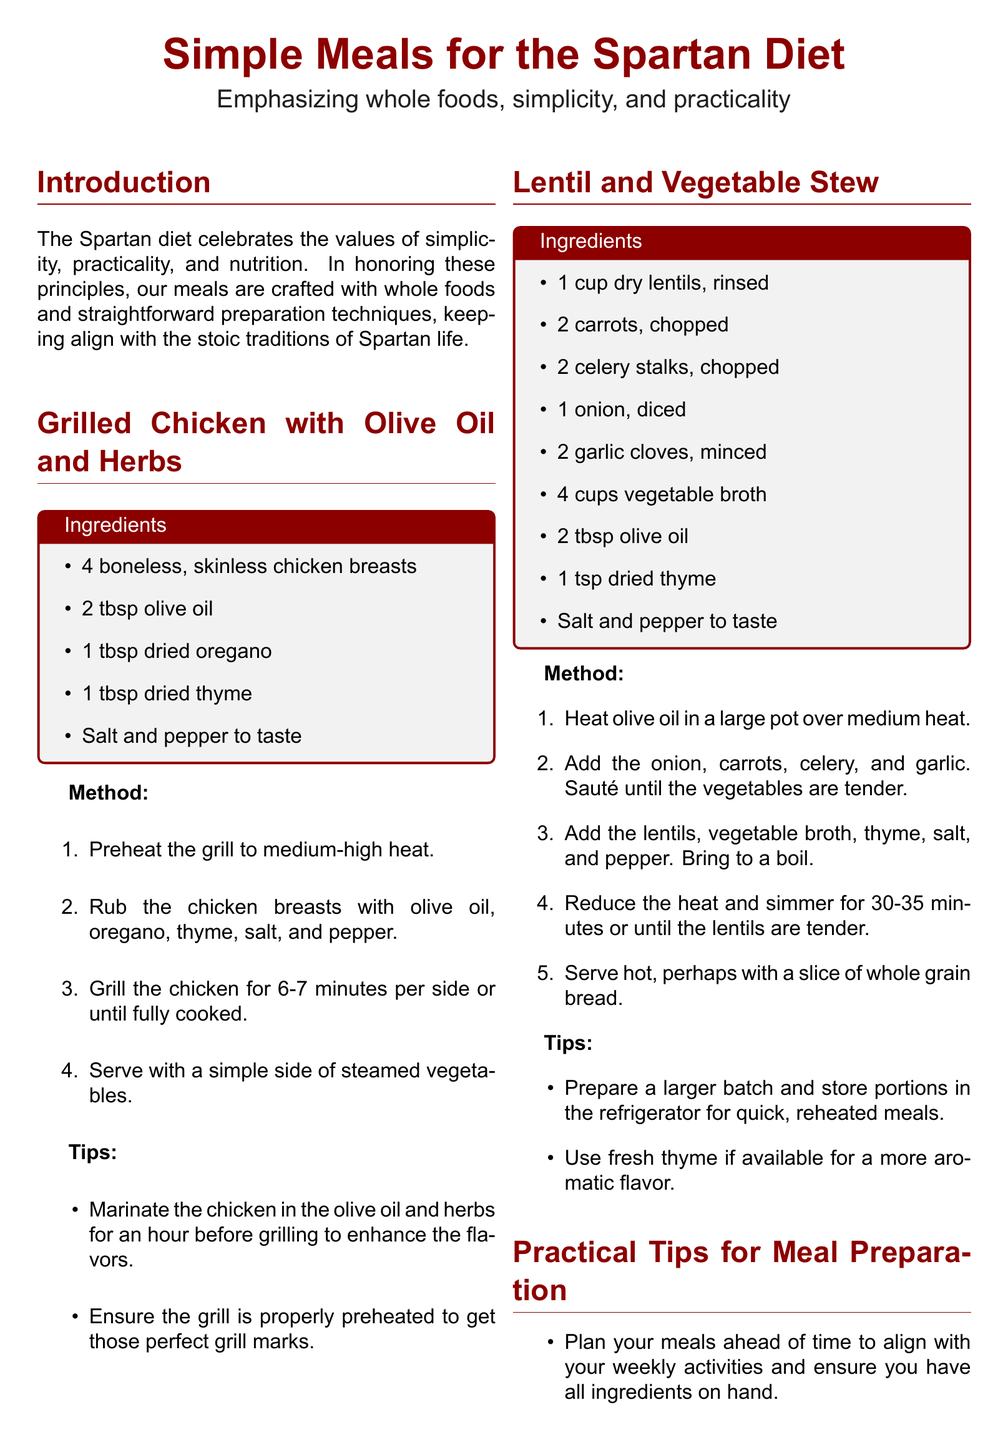What is the main focus of the recipes? The document emphasizes whole foods, simplicity, and practicality in meal preparation.
Answer: Whole foods, simplicity, and practicality How many ingredients are listed for the grilled chicken? The ingredients section provides a specific count for the grilled chicken recipe.
Answer: 5 What is the first step in grilling the chicken? The method section outlines the first action in the recipe.
Answer: Preheat the grill to medium-high heat What type of stew is featured in the document? The title of the recipe indicates the specific type of stew being discussed.
Answer: Lentil and vegetable stew What is a practical meal preparation tip mentioned? The document lists strategies to aid in meal preparation.
Answer: Plan your meals ahead of time How long should the lentils simmer? The method section specifies the time required for cooking the lentils in the stew.
Answer: 30-35 minutes What is included in the meal plan for Day 1 lunch? The table presents specific meals for different days, highlighting what is prepared for lunch.
Answer: Lentil and vegetable stew Which ingredient is suggested to enhance the flavor of grilled chicken? The tips section provides recommendations for improving the taste of the dish.
Answer: Marinate the chicken 